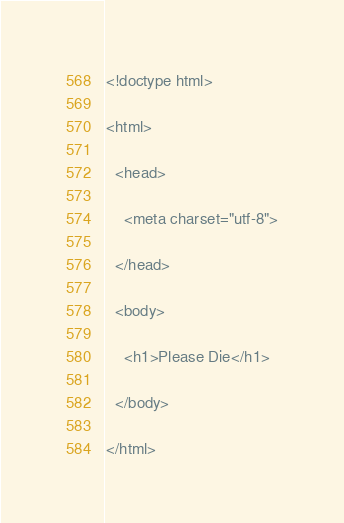Convert code to text. <code><loc_0><loc_0><loc_500><loc_500><_PHP_><!doctype html>

<html>

  <head>

    <meta charset="utf-8">

  </head>

  <body>

    <h1>Please Die</h1>

  </body>

</html></code> 